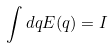Convert formula to latex. <formula><loc_0><loc_0><loc_500><loc_500>\int d q E ( q ) = I</formula> 